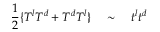<formula> <loc_0><loc_0><loc_500><loc_500>\frac { 1 } { 2 } \{ T ^ { l } T ^ { d } + T ^ { d } T ^ { l } \} \quad \sim \quad t ^ { l } t ^ { d }</formula> 